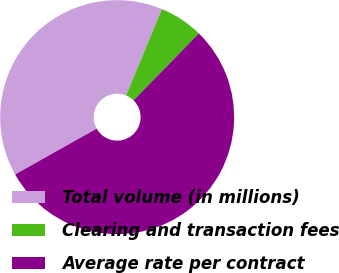Convert chart to OTSL. <chart><loc_0><loc_0><loc_500><loc_500><pie_chart><fcel>Total volume (in millions)<fcel>Clearing and transaction fees<fcel>Average rate per contract<nl><fcel>39.39%<fcel>6.06%<fcel>54.55%<nl></chart> 